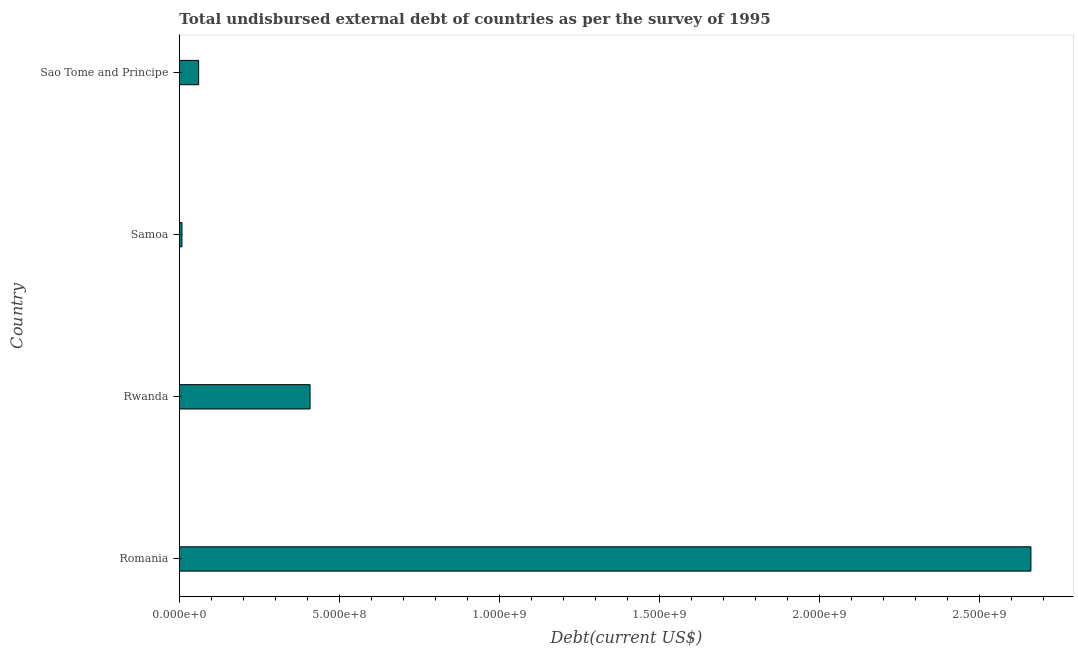Does the graph contain grids?
Your answer should be very brief. No. What is the title of the graph?
Offer a very short reply. Total undisbursed external debt of countries as per the survey of 1995. What is the label or title of the X-axis?
Give a very brief answer. Debt(current US$). What is the label or title of the Y-axis?
Provide a short and direct response. Country. What is the total debt in Samoa?
Provide a short and direct response. 7.89e+06. Across all countries, what is the maximum total debt?
Provide a short and direct response. 2.66e+09. Across all countries, what is the minimum total debt?
Ensure brevity in your answer.  7.89e+06. In which country was the total debt maximum?
Keep it short and to the point. Romania. In which country was the total debt minimum?
Provide a succinct answer. Samoa. What is the sum of the total debt?
Offer a terse response. 3.14e+09. What is the difference between the total debt in Rwanda and Sao Tome and Principe?
Your answer should be very brief. 3.48e+08. What is the average total debt per country?
Your answer should be very brief. 7.84e+08. What is the median total debt?
Provide a short and direct response. 2.34e+08. In how many countries, is the total debt greater than 2400000000 US$?
Offer a very short reply. 1. What is the ratio of the total debt in Rwanda to that in Sao Tome and Principe?
Provide a short and direct response. 6.79. Is the total debt in Rwanda less than that in Sao Tome and Principe?
Keep it short and to the point. No. What is the difference between the highest and the second highest total debt?
Ensure brevity in your answer.  2.25e+09. What is the difference between the highest and the lowest total debt?
Provide a short and direct response. 2.65e+09. How many bars are there?
Your response must be concise. 4. Are all the bars in the graph horizontal?
Keep it short and to the point. Yes. How many countries are there in the graph?
Offer a very short reply. 4. What is the difference between two consecutive major ticks on the X-axis?
Offer a terse response. 5.00e+08. What is the Debt(current US$) of Romania?
Provide a succinct answer. 2.66e+09. What is the Debt(current US$) of Rwanda?
Give a very brief answer. 4.08e+08. What is the Debt(current US$) of Samoa?
Keep it short and to the point. 7.89e+06. What is the Debt(current US$) of Sao Tome and Principe?
Your response must be concise. 6.01e+07. What is the difference between the Debt(current US$) in Romania and Rwanda?
Provide a short and direct response. 2.25e+09. What is the difference between the Debt(current US$) in Romania and Samoa?
Make the answer very short. 2.65e+09. What is the difference between the Debt(current US$) in Romania and Sao Tome and Principe?
Ensure brevity in your answer.  2.60e+09. What is the difference between the Debt(current US$) in Rwanda and Samoa?
Offer a very short reply. 4.00e+08. What is the difference between the Debt(current US$) in Rwanda and Sao Tome and Principe?
Your answer should be very brief. 3.48e+08. What is the difference between the Debt(current US$) in Samoa and Sao Tome and Principe?
Your answer should be compact. -5.22e+07. What is the ratio of the Debt(current US$) in Romania to that in Rwanda?
Offer a terse response. 6.52. What is the ratio of the Debt(current US$) in Romania to that in Samoa?
Give a very brief answer. 337.3. What is the ratio of the Debt(current US$) in Romania to that in Sao Tome and Principe?
Offer a very short reply. 44.28. What is the ratio of the Debt(current US$) in Rwanda to that in Samoa?
Your answer should be compact. 51.75. What is the ratio of the Debt(current US$) in Rwanda to that in Sao Tome and Principe?
Ensure brevity in your answer.  6.79. What is the ratio of the Debt(current US$) in Samoa to that in Sao Tome and Principe?
Offer a terse response. 0.13. 